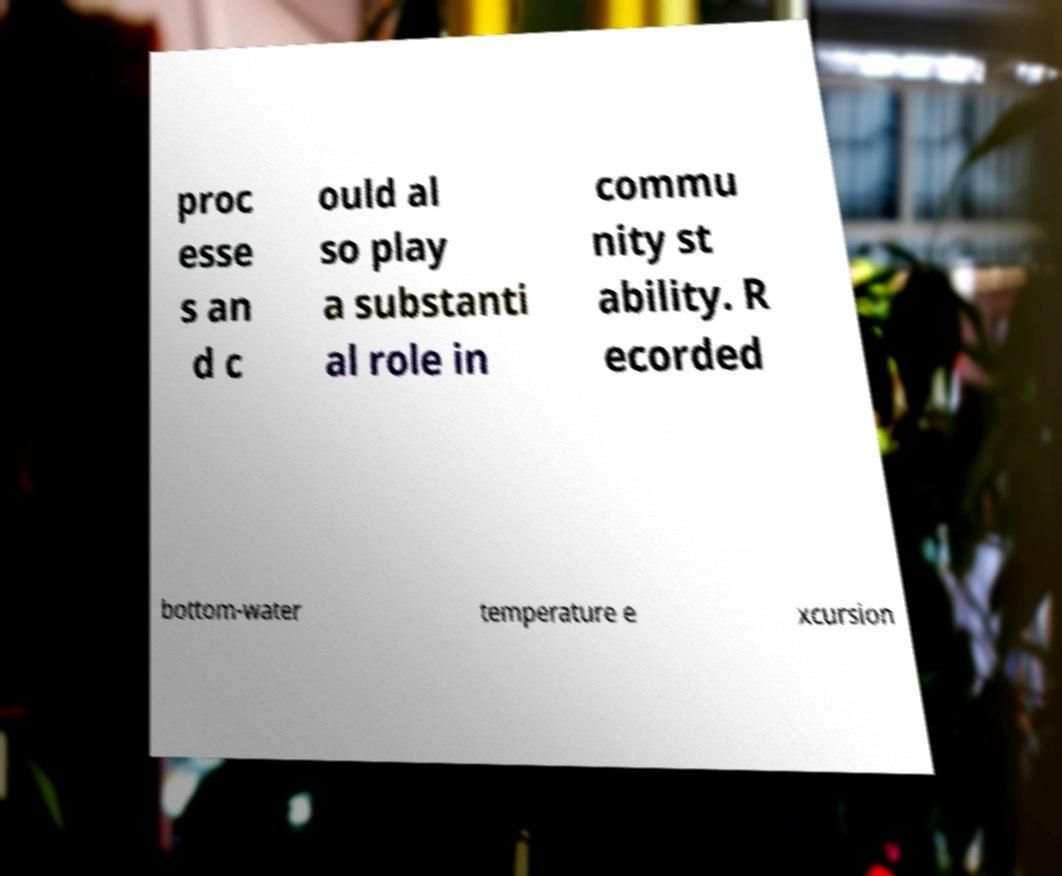Could you assist in decoding the text presented in this image and type it out clearly? proc esse s an d c ould al so play a substanti al role in commu nity st ability. R ecorded bottom-water temperature e xcursion 